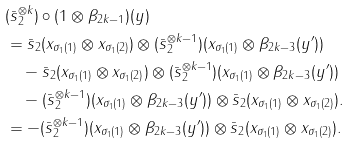<formula> <loc_0><loc_0><loc_500><loc_500>& ( \bar { s } _ { 2 } ^ { \otimes k } ) \circ ( 1 \otimes \beta _ { 2 k - 1 } ) ( y ) \\ & = \bar { s } _ { 2 } ( x _ { \sigma _ { 1 } ( 1 ) } \otimes x _ { \sigma _ { 1 } ( 2 ) } ) \otimes ( \bar { s } _ { 2 } ^ { \otimes k - 1 } ) ( x _ { \sigma _ { 1 } ( 1 ) } \otimes \beta _ { 2 k - 3 } ( y ^ { \prime } ) ) \\ & \quad - \bar { s } _ { 2 } ( x _ { \sigma _ { 1 } ( 1 ) } \otimes x _ { \sigma _ { 1 } ( 2 ) } ) \otimes ( \bar { s } _ { 2 } ^ { \otimes k - 1 } ) ( x _ { \sigma _ { 1 } ( 1 ) } \otimes \beta _ { 2 k - 3 } ( y ^ { \prime } ) ) \\ & \quad - ( \bar { s } _ { 2 } ^ { \otimes k - 1 } ) ( x _ { \sigma _ { 1 } ( 1 ) } \otimes \beta _ { 2 k - 3 } ( y ^ { \prime } ) ) \otimes \bar { s } _ { 2 } ( x _ { \sigma _ { 1 } ( 1 ) } \otimes x _ { \sigma _ { 1 } ( 2 ) } ) . \\ & = - ( \bar { s } _ { 2 } ^ { \otimes k - 1 } ) ( x _ { \sigma _ { 1 } ( 1 ) } \otimes \beta _ { 2 k - 3 } ( y ^ { \prime } ) ) \otimes \bar { s } _ { 2 } ( x _ { \sigma _ { 1 } ( 1 ) } \otimes x _ { \sigma _ { 1 } ( 2 ) } ) .</formula> 